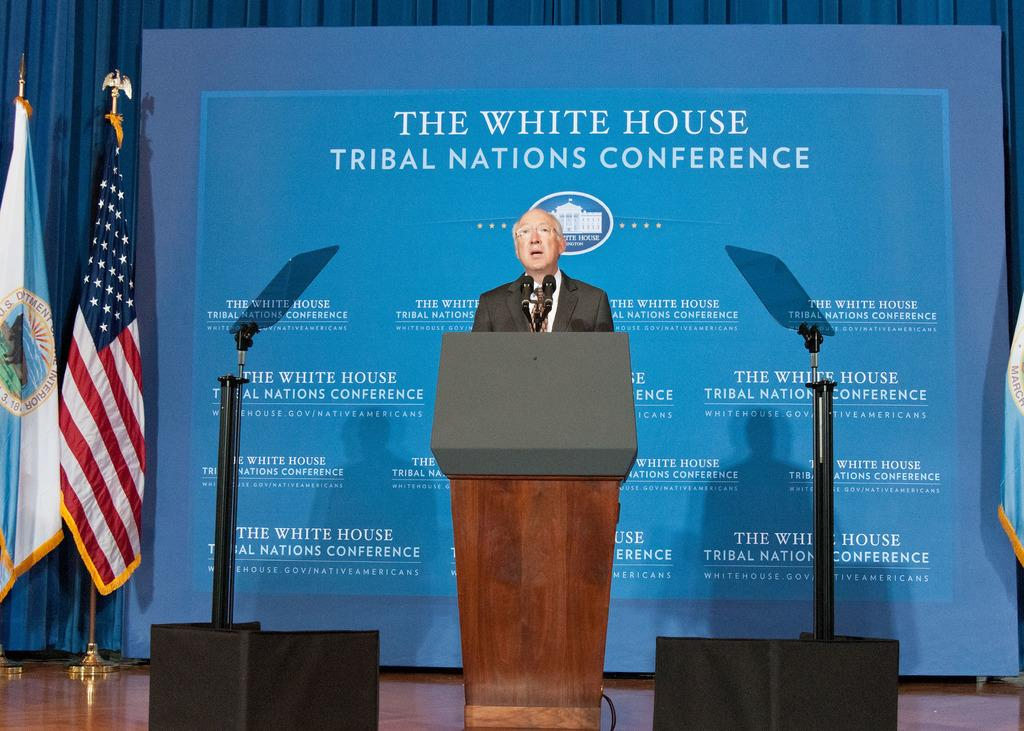What is the person in the image doing? The person is standing and talking in front of a microphone. What can be seen in the background of the image? There is a flag and a big banner visible in the image. What type of cart is being pulled by the ray in the image? There is no ray or cart present in the image. 